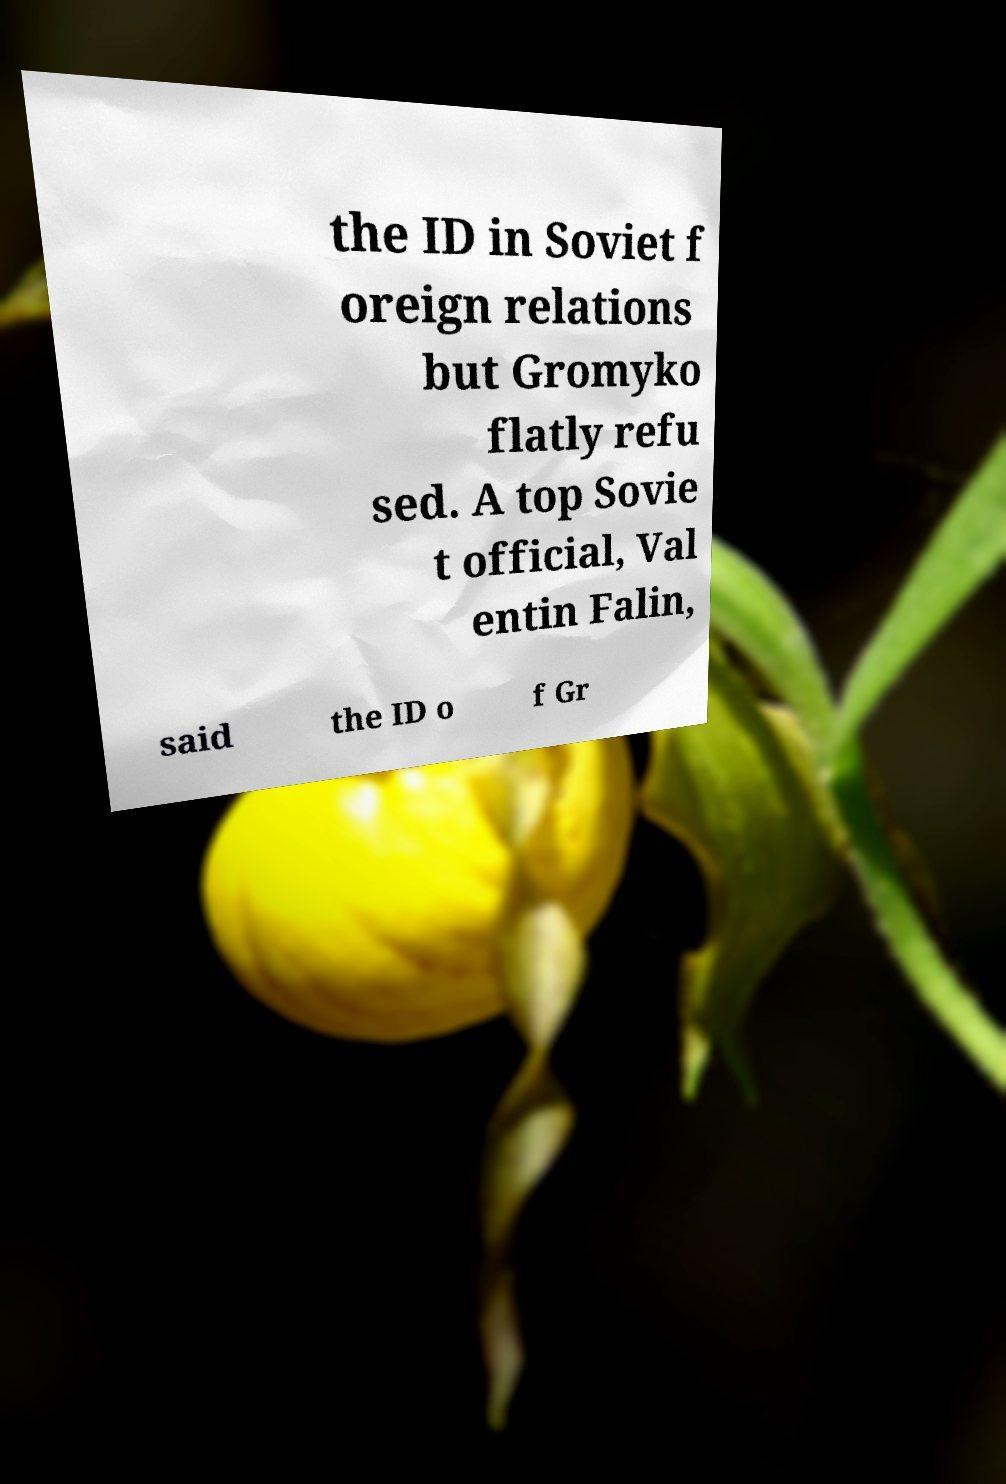Could you assist in decoding the text presented in this image and type it out clearly? the ID in Soviet f oreign relations but Gromyko flatly refu sed. A top Sovie t official, Val entin Falin, said the ID o f Gr 